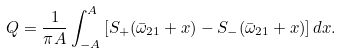<formula> <loc_0><loc_0><loc_500><loc_500>Q = \frac { 1 } { \pi A } \int \nolimits _ { - A } ^ { A } \left [ S _ { + } ( \bar { \omega } _ { 2 1 } + x ) - S _ { - } ( \bar { \omega } _ { 2 1 } + x ) \right ] d x .</formula> 